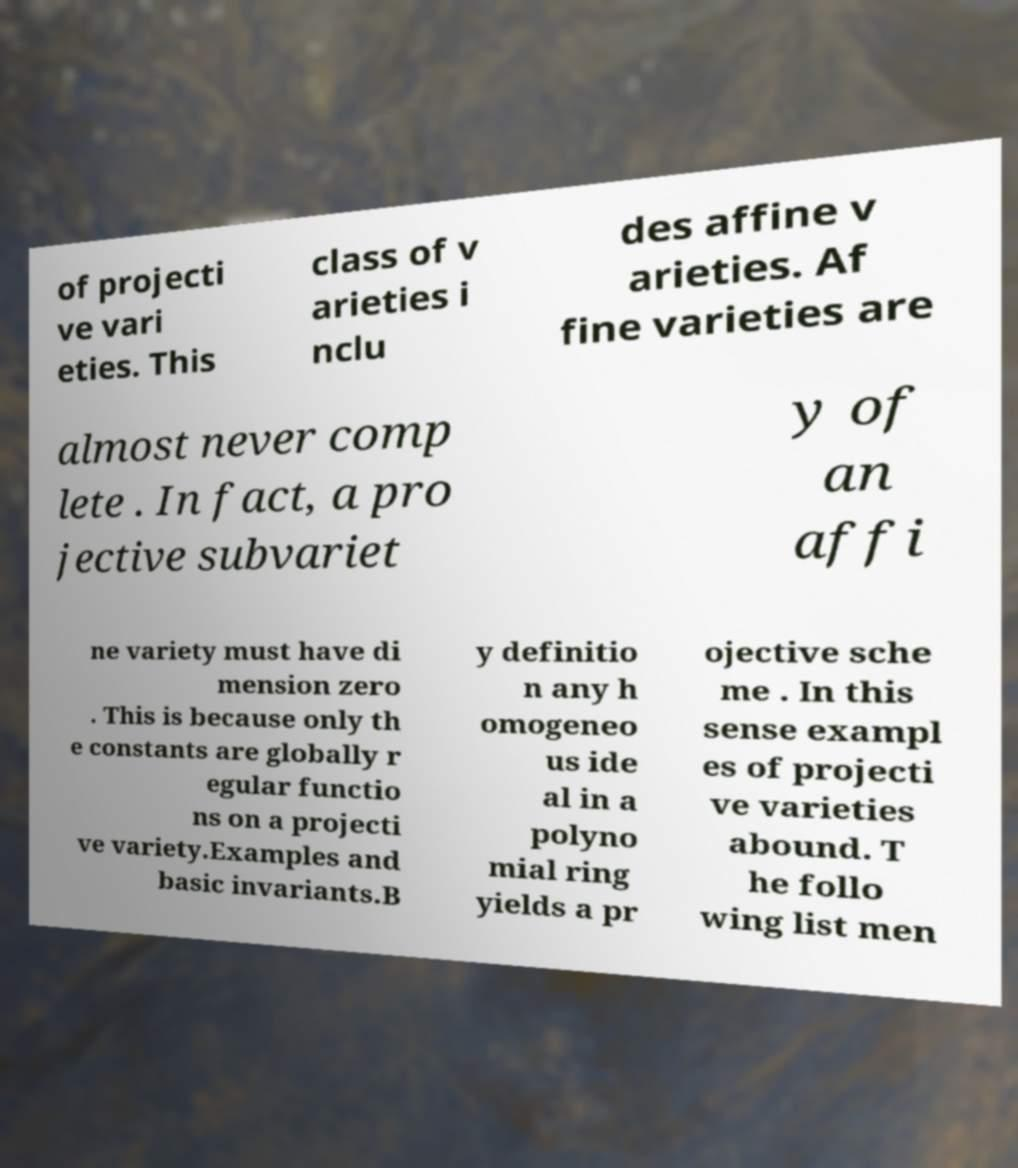There's text embedded in this image that I need extracted. Can you transcribe it verbatim? of projecti ve vari eties. This class of v arieties i nclu des affine v arieties. Af fine varieties are almost never comp lete . In fact, a pro jective subvariet y of an affi ne variety must have di mension zero . This is because only th e constants are globally r egular functio ns on a projecti ve variety.Examples and basic invariants.B y definitio n any h omogeneo us ide al in a polyno mial ring yields a pr ojective sche me . In this sense exampl es of projecti ve varieties abound. T he follo wing list men 